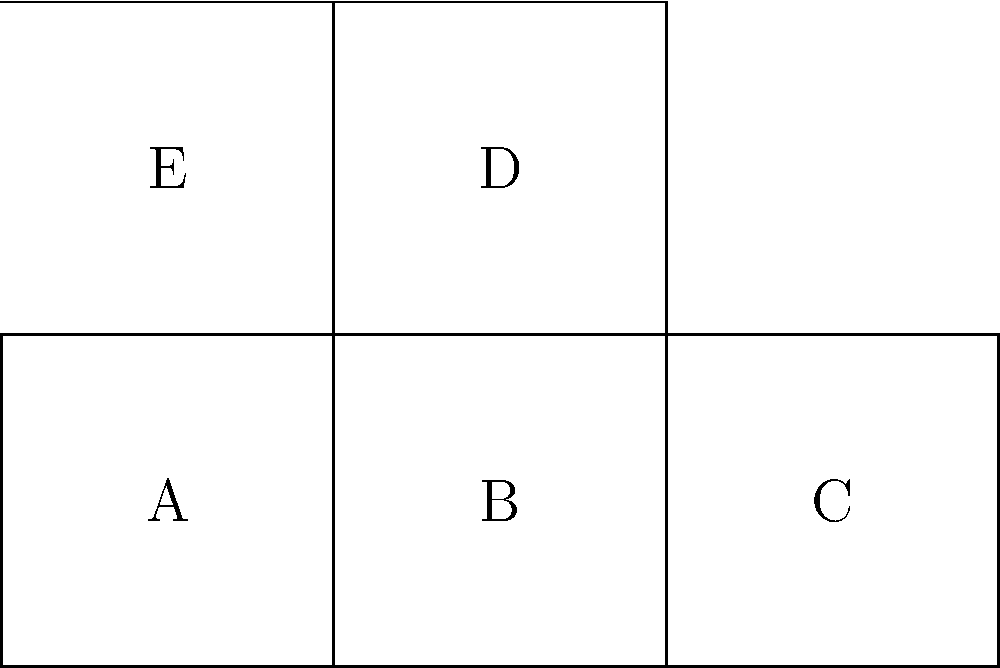Which 3D shape would be formed if the given 2D net is folded along its edges? To determine the 3D shape formed by folding this net, let's follow these steps:

1. Identify the shape of the base: The base is a square (face A).

2. Count the number of faces: There are 5 faces in total (A, B, C, D, and E).

3. Analyze the arrangement:
   - Four faces (B, C, D, E) are attached to the edges of the base (A).
   - These four faces form the sides of the 3D shape.

4. Visualize the folding process:
   - Faces B and C will fold up to form two opposite sides.
   - Faces D and E will fold up to form the other two opposite sides.
   - All four side faces (B, C, D, E) are rectangles.

5. Consider the top:
   - There is no face to cover the top of the shape.
   - This indicates that the shape is open at the top.

6. Conclude the shape:
   - A square base with four rectangular sides and an open top forms an open cube, also known as a cubic frustum or an open box.

Therefore, when folded, this net will form an open cube or box with a square base and four rectangular sides, but no top face.
Answer: Open cube (or open box) 